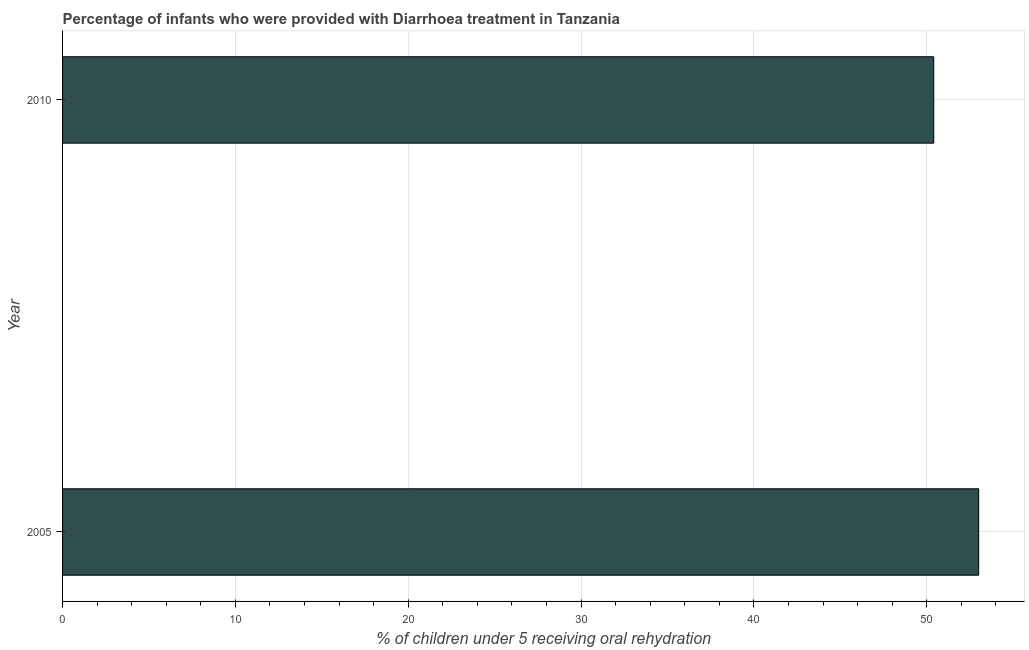Does the graph contain grids?
Give a very brief answer. Yes. What is the title of the graph?
Give a very brief answer. Percentage of infants who were provided with Diarrhoea treatment in Tanzania. What is the label or title of the X-axis?
Your response must be concise. % of children under 5 receiving oral rehydration. What is the label or title of the Y-axis?
Your answer should be very brief. Year. What is the percentage of children who were provided with treatment diarrhoea in 2005?
Your answer should be compact. 53. Across all years, what is the minimum percentage of children who were provided with treatment diarrhoea?
Your response must be concise. 50.4. What is the sum of the percentage of children who were provided with treatment diarrhoea?
Your response must be concise. 103.4. What is the difference between the percentage of children who were provided with treatment diarrhoea in 2005 and 2010?
Give a very brief answer. 2.6. What is the average percentage of children who were provided with treatment diarrhoea per year?
Your answer should be very brief. 51.7. What is the median percentage of children who were provided with treatment diarrhoea?
Offer a very short reply. 51.7. In how many years, is the percentage of children who were provided with treatment diarrhoea greater than 28 %?
Provide a short and direct response. 2. Do a majority of the years between 2010 and 2005 (inclusive) have percentage of children who were provided with treatment diarrhoea greater than 32 %?
Give a very brief answer. No. What is the ratio of the percentage of children who were provided with treatment diarrhoea in 2005 to that in 2010?
Keep it short and to the point. 1.05. How many bars are there?
Offer a terse response. 2. Are all the bars in the graph horizontal?
Your answer should be compact. Yes. How many years are there in the graph?
Make the answer very short. 2. What is the difference between two consecutive major ticks on the X-axis?
Your answer should be compact. 10. Are the values on the major ticks of X-axis written in scientific E-notation?
Offer a terse response. No. What is the % of children under 5 receiving oral rehydration in 2005?
Make the answer very short. 53. What is the % of children under 5 receiving oral rehydration of 2010?
Provide a short and direct response. 50.4. What is the ratio of the % of children under 5 receiving oral rehydration in 2005 to that in 2010?
Your answer should be very brief. 1.05. 